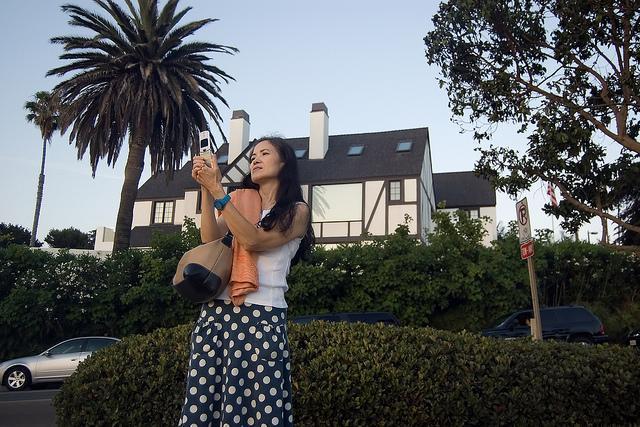How many people are there?
Give a very brief answer. 1. How many vehicles are in the background?
Give a very brief answer. 3. How many cars are there?
Give a very brief answer. 2. How many clock faces are shown?
Give a very brief answer. 0. 